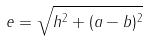Convert formula to latex. <formula><loc_0><loc_0><loc_500><loc_500>e = \sqrt { h ^ { 2 } + ( a - b ) ^ { 2 } }</formula> 